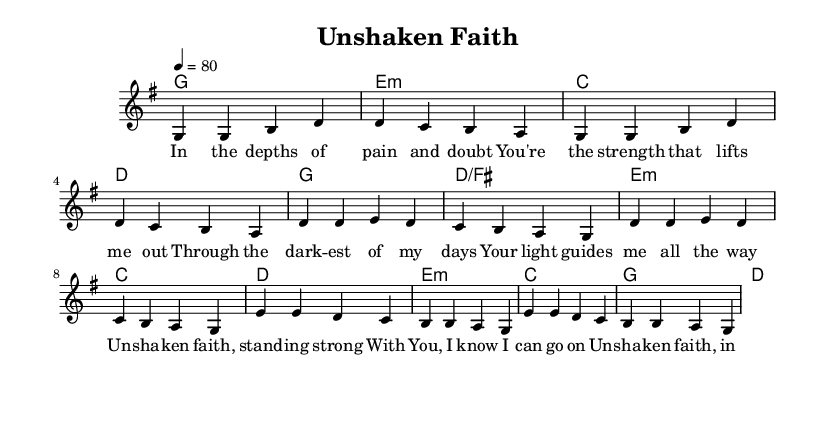What is the key signature of this music? The key signature is G major, which has one sharp, F#. This can be identified by looking at the key signature marking at the beginning of the staff.
Answer: G major What is the time signature of this piece? The time signature is 4/4, which means there are four beats in each measure and the quarter note gets one beat. This is indicated at the beginning of the score.
Answer: 4/4 What is the tempo marking for this piece? The tempo marking is 80 beats per minute. This gives the performer an indication of the speed at which the music should be played, mentioned in the tempo directive.
Answer: 80 How many measures are in the verse section? The verse section consists of four measures. This can be counted from the notation in the melody section where the verse lyrics are aligned.
Answer: 4 What is the repeated phrase in the chorus? The repeated phrase in the chorus is "Un-sha-ken faith." This can be identified as it is highlighted in the lyrics portion and occurs multiple times.
Answer: Un-sha-ken faith What is the main message conveyed in the lyrics of the bridge? The main message in the bridge focuses on resilience, stating, "I'll rise up again." This can be determined by analyzing the content of the bridge lyrics which emphasizes overcoming struggles.
Answer: I'll rise up again How does the harmony support the melody in the chorus? The harmony supports the melody by using chords that complement the vocal line, specifically F# in D/F# and resolving back to G. By examining the chord progressions beneath the melody, we can see this relationship clearly.
Answer: F# in D/F# 